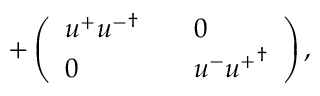<formula> <loc_0><loc_0><loc_500><loc_500>+ \left ( \begin{array} { l l l } { { u ^ { + } { u ^ { - } } ^ { \dagger } } } & { 0 } \\ { 0 } & { { u ^ { - } { u ^ { + } } ^ { \dagger } } } \end{array} \right ) ,</formula> 